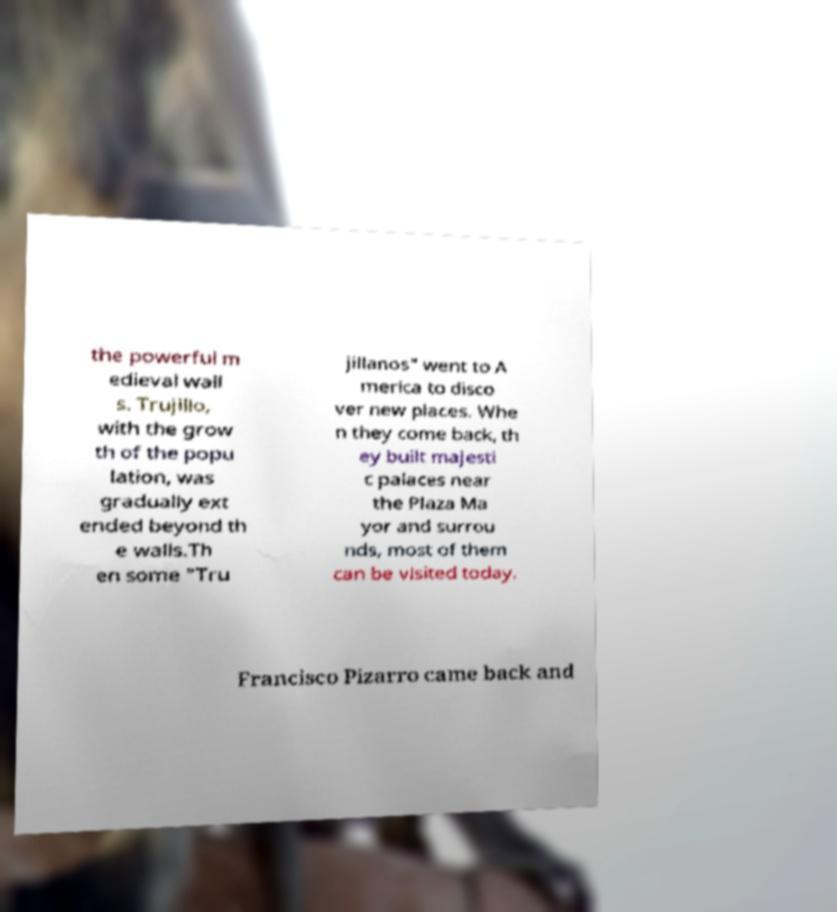What messages or text are displayed in this image? I need them in a readable, typed format. the powerful m edieval wall s. Trujillo, with the grow th of the popu lation, was gradually ext ended beyond th e walls.Th en some "Tru jillanos" went to A merica to disco ver new places. Whe n they come back, th ey built majesti c palaces near the Plaza Ma yor and surrou nds, most of them can be visited today. Francisco Pizarro came back and 